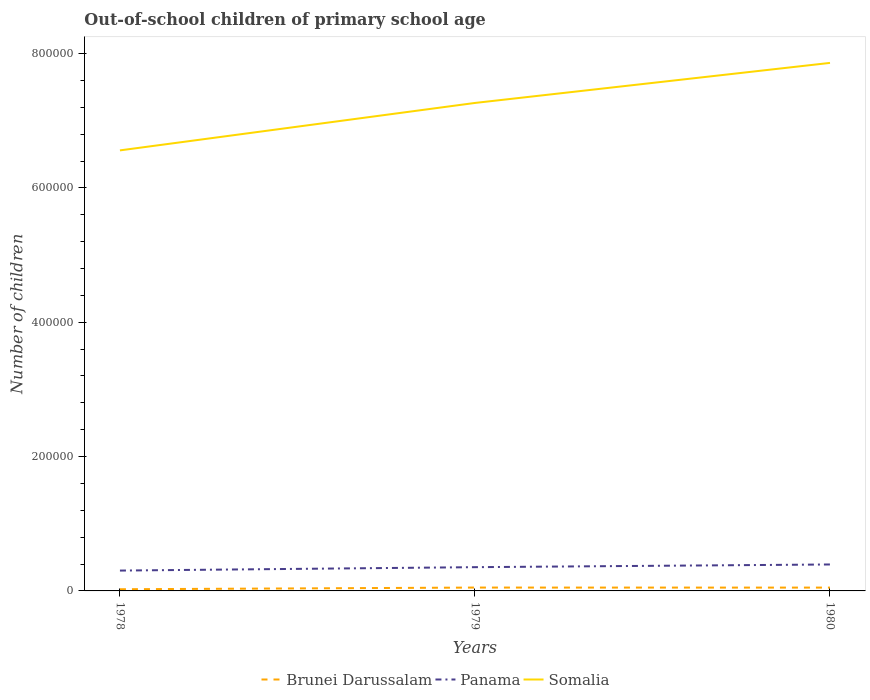Does the line corresponding to Panama intersect with the line corresponding to Somalia?
Ensure brevity in your answer.  No. Is the number of lines equal to the number of legend labels?
Offer a very short reply. Yes. Across all years, what is the maximum number of out-of-school children in Brunei Darussalam?
Make the answer very short. 2490. In which year was the number of out-of-school children in Brunei Darussalam maximum?
Offer a terse response. 1978. What is the total number of out-of-school children in Somalia in the graph?
Keep it short and to the point. -7.06e+04. What is the difference between the highest and the second highest number of out-of-school children in Brunei Darussalam?
Offer a very short reply. 2509. What is the difference between the highest and the lowest number of out-of-school children in Brunei Darussalam?
Your response must be concise. 2. What is the difference between two consecutive major ticks on the Y-axis?
Ensure brevity in your answer.  2.00e+05. Does the graph contain any zero values?
Give a very brief answer. No. Where does the legend appear in the graph?
Offer a terse response. Bottom center. How many legend labels are there?
Give a very brief answer. 3. What is the title of the graph?
Make the answer very short. Out-of-school children of primary school age. What is the label or title of the X-axis?
Offer a very short reply. Years. What is the label or title of the Y-axis?
Provide a succinct answer. Number of children. What is the Number of children in Brunei Darussalam in 1978?
Make the answer very short. 2490. What is the Number of children in Panama in 1978?
Keep it short and to the point. 3.03e+04. What is the Number of children of Somalia in 1978?
Provide a short and direct response. 6.56e+05. What is the Number of children in Brunei Darussalam in 1979?
Your answer should be very brief. 4999. What is the Number of children in Panama in 1979?
Your answer should be compact. 3.54e+04. What is the Number of children in Somalia in 1979?
Your answer should be very brief. 7.26e+05. What is the Number of children in Brunei Darussalam in 1980?
Offer a terse response. 4944. What is the Number of children of Panama in 1980?
Ensure brevity in your answer.  3.94e+04. What is the Number of children of Somalia in 1980?
Your response must be concise. 7.86e+05. Across all years, what is the maximum Number of children in Brunei Darussalam?
Provide a short and direct response. 4999. Across all years, what is the maximum Number of children in Panama?
Provide a short and direct response. 3.94e+04. Across all years, what is the maximum Number of children of Somalia?
Give a very brief answer. 7.86e+05. Across all years, what is the minimum Number of children of Brunei Darussalam?
Give a very brief answer. 2490. Across all years, what is the minimum Number of children in Panama?
Your answer should be very brief. 3.03e+04. Across all years, what is the minimum Number of children of Somalia?
Your response must be concise. 6.56e+05. What is the total Number of children of Brunei Darussalam in the graph?
Offer a very short reply. 1.24e+04. What is the total Number of children in Panama in the graph?
Provide a short and direct response. 1.05e+05. What is the total Number of children of Somalia in the graph?
Ensure brevity in your answer.  2.17e+06. What is the difference between the Number of children in Brunei Darussalam in 1978 and that in 1979?
Your answer should be very brief. -2509. What is the difference between the Number of children of Panama in 1978 and that in 1979?
Offer a very short reply. -5066. What is the difference between the Number of children of Somalia in 1978 and that in 1979?
Give a very brief answer. -7.06e+04. What is the difference between the Number of children of Brunei Darussalam in 1978 and that in 1980?
Keep it short and to the point. -2454. What is the difference between the Number of children in Panama in 1978 and that in 1980?
Keep it short and to the point. -9079. What is the difference between the Number of children in Somalia in 1978 and that in 1980?
Make the answer very short. -1.30e+05. What is the difference between the Number of children in Brunei Darussalam in 1979 and that in 1980?
Give a very brief answer. 55. What is the difference between the Number of children in Panama in 1979 and that in 1980?
Provide a succinct answer. -4013. What is the difference between the Number of children of Somalia in 1979 and that in 1980?
Provide a short and direct response. -5.96e+04. What is the difference between the Number of children of Brunei Darussalam in 1978 and the Number of children of Panama in 1979?
Offer a terse response. -3.29e+04. What is the difference between the Number of children in Brunei Darussalam in 1978 and the Number of children in Somalia in 1979?
Keep it short and to the point. -7.24e+05. What is the difference between the Number of children in Panama in 1978 and the Number of children in Somalia in 1979?
Ensure brevity in your answer.  -6.96e+05. What is the difference between the Number of children in Brunei Darussalam in 1978 and the Number of children in Panama in 1980?
Ensure brevity in your answer.  -3.69e+04. What is the difference between the Number of children of Brunei Darussalam in 1978 and the Number of children of Somalia in 1980?
Make the answer very short. -7.84e+05. What is the difference between the Number of children of Panama in 1978 and the Number of children of Somalia in 1980?
Keep it short and to the point. -7.56e+05. What is the difference between the Number of children of Brunei Darussalam in 1979 and the Number of children of Panama in 1980?
Offer a terse response. -3.44e+04. What is the difference between the Number of children of Brunei Darussalam in 1979 and the Number of children of Somalia in 1980?
Provide a succinct answer. -7.81e+05. What is the difference between the Number of children in Panama in 1979 and the Number of children in Somalia in 1980?
Make the answer very short. -7.51e+05. What is the average Number of children in Brunei Darussalam per year?
Your response must be concise. 4144.33. What is the average Number of children of Panama per year?
Ensure brevity in your answer.  3.50e+04. What is the average Number of children in Somalia per year?
Your answer should be compact. 7.23e+05. In the year 1978, what is the difference between the Number of children in Brunei Darussalam and Number of children in Panama?
Provide a succinct answer. -2.78e+04. In the year 1978, what is the difference between the Number of children of Brunei Darussalam and Number of children of Somalia?
Your answer should be compact. -6.53e+05. In the year 1978, what is the difference between the Number of children in Panama and Number of children in Somalia?
Offer a terse response. -6.26e+05. In the year 1979, what is the difference between the Number of children of Brunei Darussalam and Number of children of Panama?
Give a very brief answer. -3.04e+04. In the year 1979, what is the difference between the Number of children of Brunei Darussalam and Number of children of Somalia?
Offer a very short reply. -7.21e+05. In the year 1979, what is the difference between the Number of children in Panama and Number of children in Somalia?
Offer a very short reply. -6.91e+05. In the year 1980, what is the difference between the Number of children in Brunei Darussalam and Number of children in Panama?
Offer a very short reply. -3.44e+04. In the year 1980, what is the difference between the Number of children in Brunei Darussalam and Number of children in Somalia?
Offer a terse response. -7.81e+05. In the year 1980, what is the difference between the Number of children in Panama and Number of children in Somalia?
Ensure brevity in your answer.  -7.47e+05. What is the ratio of the Number of children in Brunei Darussalam in 1978 to that in 1979?
Keep it short and to the point. 0.5. What is the ratio of the Number of children in Panama in 1978 to that in 1979?
Your response must be concise. 0.86. What is the ratio of the Number of children of Somalia in 1978 to that in 1979?
Provide a short and direct response. 0.9. What is the ratio of the Number of children in Brunei Darussalam in 1978 to that in 1980?
Keep it short and to the point. 0.5. What is the ratio of the Number of children in Panama in 1978 to that in 1980?
Offer a very short reply. 0.77. What is the ratio of the Number of children in Somalia in 1978 to that in 1980?
Give a very brief answer. 0.83. What is the ratio of the Number of children of Brunei Darussalam in 1979 to that in 1980?
Provide a short and direct response. 1.01. What is the ratio of the Number of children in Panama in 1979 to that in 1980?
Keep it short and to the point. 0.9. What is the ratio of the Number of children of Somalia in 1979 to that in 1980?
Provide a succinct answer. 0.92. What is the difference between the highest and the second highest Number of children in Brunei Darussalam?
Your response must be concise. 55. What is the difference between the highest and the second highest Number of children of Panama?
Make the answer very short. 4013. What is the difference between the highest and the second highest Number of children of Somalia?
Ensure brevity in your answer.  5.96e+04. What is the difference between the highest and the lowest Number of children in Brunei Darussalam?
Your answer should be very brief. 2509. What is the difference between the highest and the lowest Number of children of Panama?
Make the answer very short. 9079. What is the difference between the highest and the lowest Number of children in Somalia?
Offer a terse response. 1.30e+05. 